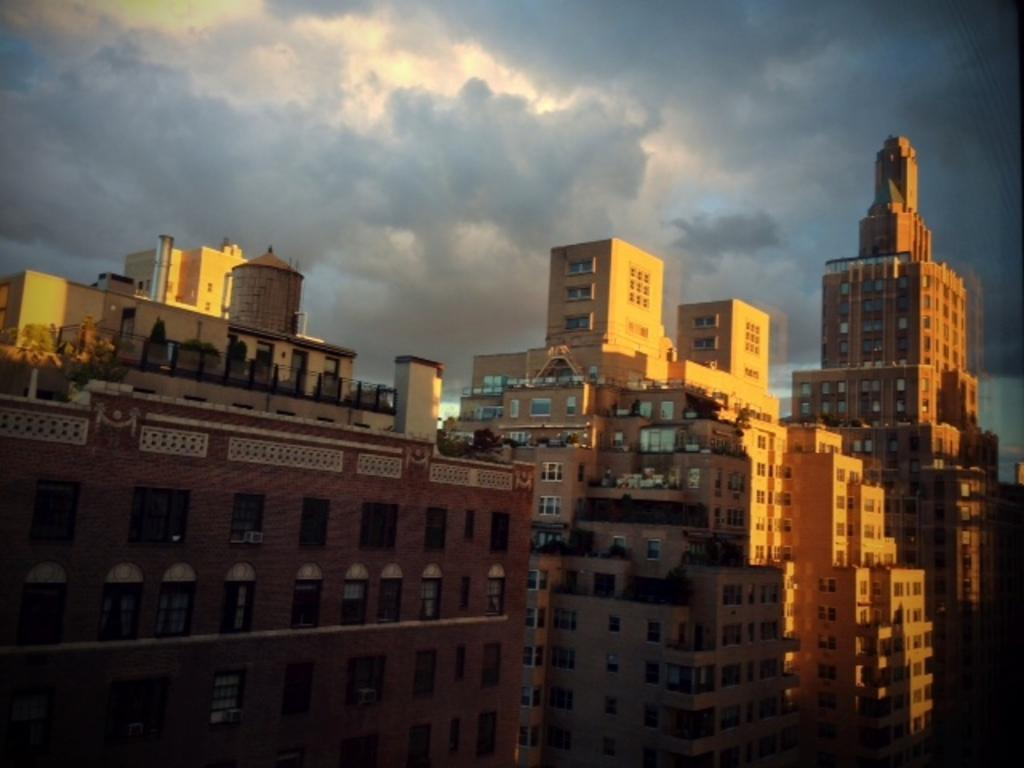What type of structures are present in the image? There are buildings in the image. What can be seen in the sky at the top of the image? There are clouds visible in the sky at the top of the image. How many apples are being divided among the buildings in the image? There are no apples present in the image, and therefore no division operation is taking place. 